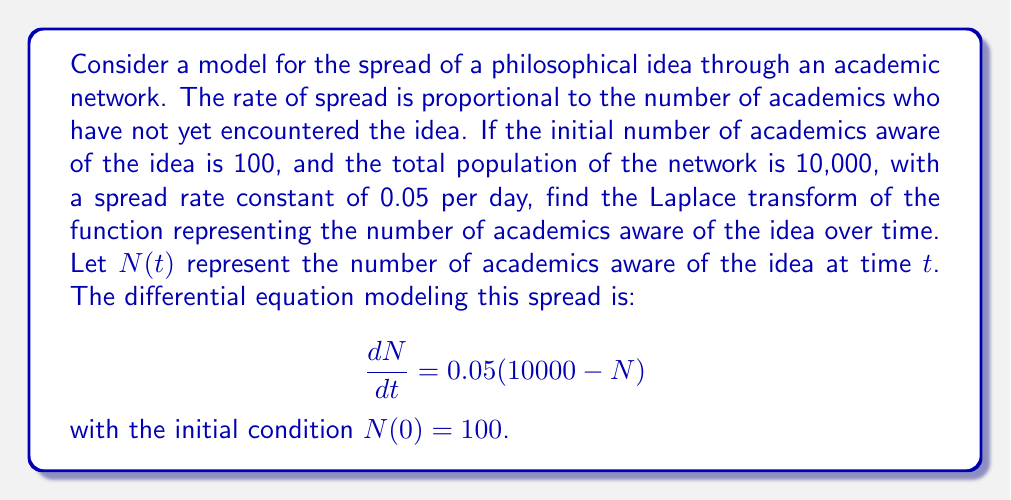Teach me how to tackle this problem. To solve this problem, we'll follow these steps:

1) First, let's rearrange the differential equation:
   $$\frac{dN}{dt} + 0.05N = 500$$

2) This is a first-order linear differential equation. Its solution is of the form:
   $$N(t) = Ce^{-0.05t} + 10000$$
   where $C$ is a constant we need to determine.

3) Using the initial condition $N(0) = 100$:
   $$100 = C + 10000$$
   $$C = -9900$$

4) Therefore, the function $N(t)$ is:
   $$N(t) = 10000 - 9900e^{-0.05t}$$

5) Now, we need to find the Laplace transform of this function. Let's denote the Laplace transform as $\mathcal{L}\{N(t)\} = F(s)$.

6) We can split this into two parts:
   $$F(s) = \mathcal{L}\{10000\} - 9900\mathcal{L}\{e^{-0.05t}\}$$

7) We know that:
   - $\mathcal{L}\{k\} = \frac{k}{s}$ for a constant $k$
   - $\mathcal{L}\{e^{at}\} = \frac{1}{s-a}$

8) Applying these:
   $$F(s) = \frac{10000}{s} - 9900 \cdot \frac{1}{s+0.05}$$

9) Simplifying:
   $$F(s) = \frac{10000}{s} - \frac{9900}{s+0.05}$$

10) Finding a common denominator:
    $$F(s) = \frac{10000(s+0.05) - 9900s}{s(s+0.05)}$$

11) Simplifying the numerator:
    $$F(s) = \frac{10000s + 500 - 9900s}{s(s+0.05)} = \frac{100s + 500}{s(s+0.05)}$$
Answer: The Laplace transform of the function representing the number of academics aware of the idea over time is:

$$F(s) = \frac{100s + 500}{s(s+0.05)}$$ 